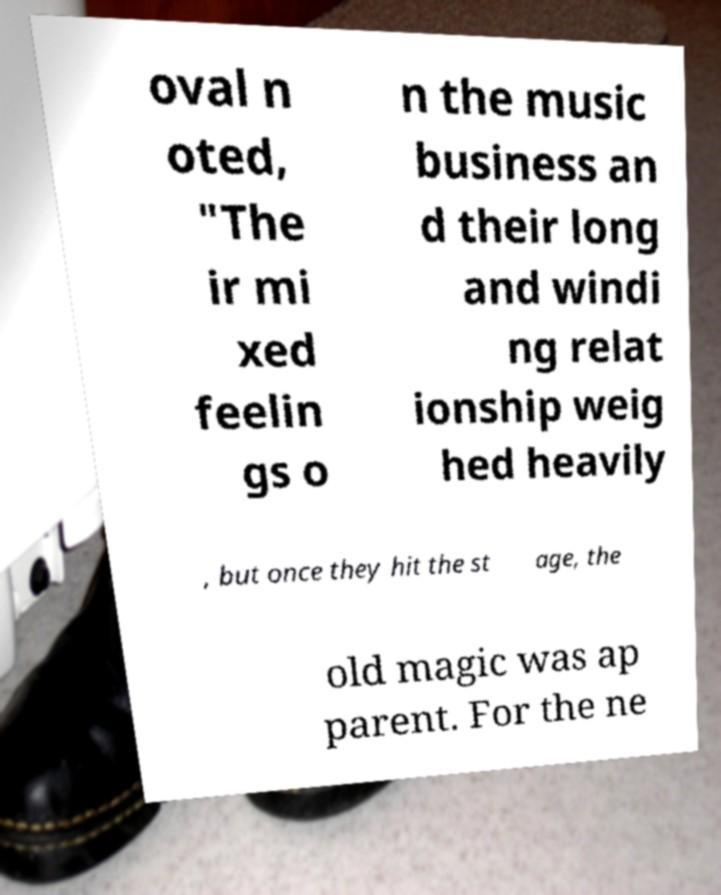Could you assist in decoding the text presented in this image and type it out clearly? oval n oted, "The ir mi xed feelin gs o n the music business an d their long and windi ng relat ionship weig hed heavily , but once they hit the st age, the old magic was ap parent. For the ne 